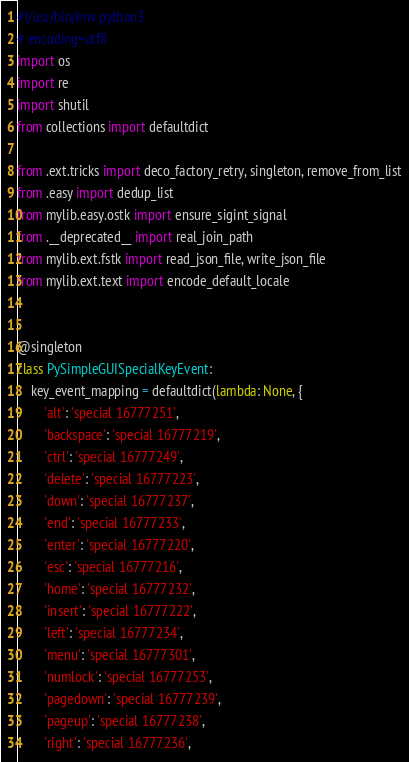<code> <loc_0><loc_0><loc_500><loc_500><_Python_>#!/usr/bin/env python3
# encoding=utf8
import os
import re
import shutil
from collections import defaultdict

from .ext.tricks import deco_factory_retry, singleton, remove_from_list
from .easy import dedup_list
from mylib.easy.ostk import ensure_sigint_signal
from .__deprecated__ import real_join_path
from mylib.ext.fstk import read_json_file, write_json_file
from mylib.ext.text import encode_default_locale


@singleton
class PySimpleGUISpecialKeyEvent:
    key_event_mapping = defaultdict(lambda: None, {
        'alt': 'special 16777251',
        'backspace': 'special 16777219',
        'ctrl': 'special 16777249',
        'delete': 'special 16777223',
        'down': 'special 16777237',
        'end': 'special 16777233',
        'enter': 'special 16777220',
        'esc': 'special 16777216',
        'home': 'special 16777232',
        'insert': 'special 16777222',
        'left': 'special 16777234',
        'menu': 'special 16777301',
        'numlock': 'special 16777253',
        'pagedown': 'special 16777239',
        'pageup': 'special 16777238',
        'right': 'special 16777236',</code> 